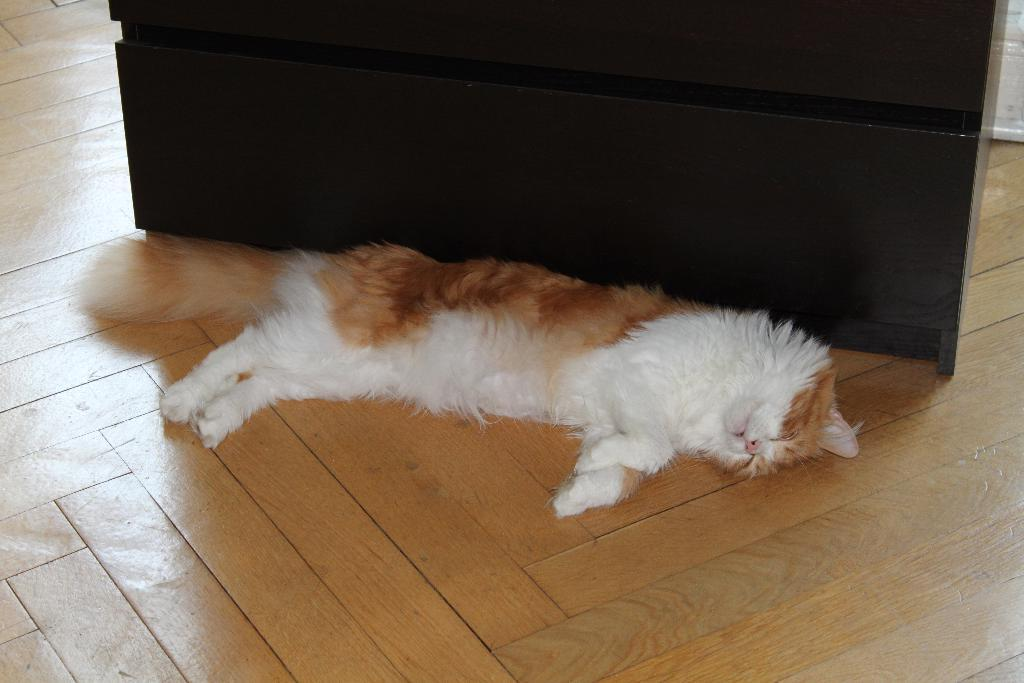What type of animal is in the image? There is a cat in the image. What is the cat doing in the image? The cat is sleeping on the floor. Can you describe the color of the cat? The cat is white and brown in color. What can be seen in the background of the image? There are objects in the background of the image. What is the color of the objects in the background? The objects in the background are brown in color. What type of cap is the cat wearing in the image? There is no cap present in the image; the cat is not wearing any clothing. 